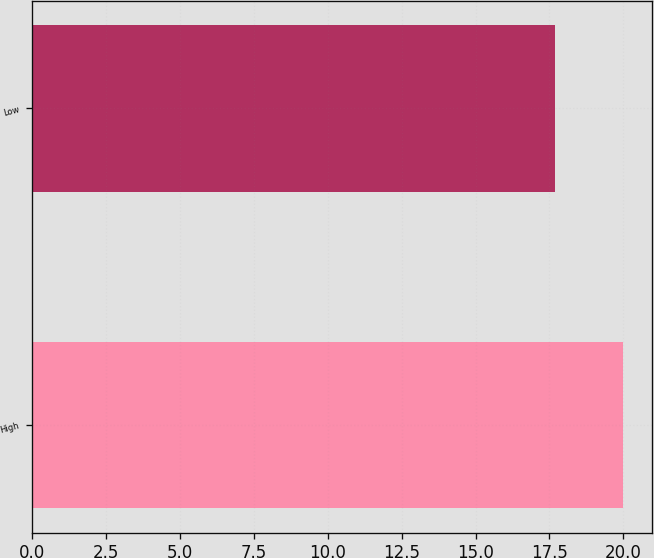Convert chart to OTSL. <chart><loc_0><loc_0><loc_500><loc_500><bar_chart><fcel>High<fcel>Low<nl><fcel>19.97<fcel>17.7<nl></chart> 